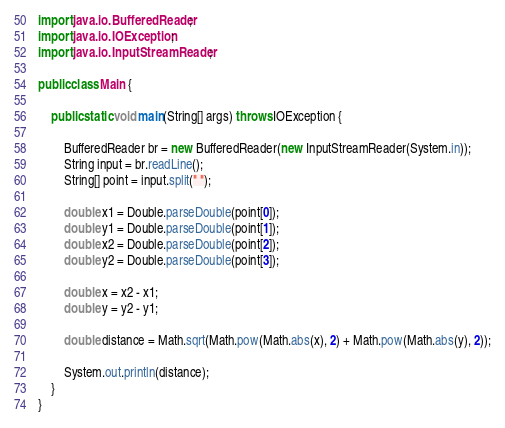<code> <loc_0><loc_0><loc_500><loc_500><_Java_>import java.io.BufferedReader;
import java.io.IOException;
import java.io.InputStreamReader;

public class Main {

    public static void main(String[] args) throws IOException {

        BufferedReader br = new BufferedReader(new InputStreamReader(System.in));
        String input = br.readLine();
        String[] point = input.split(" ");

        double x1 = Double.parseDouble(point[0]);
        double y1 = Double.parseDouble(point[1]);
        double x2 = Double.parseDouble(point[2]);
        double y2 = Double.parseDouble(point[3]);

        double x = x2 - x1;
        double y = y2 - y1;

        double distance = Math.sqrt(Math.pow(Math.abs(x), 2) + Math.pow(Math.abs(y), 2));

        System.out.println(distance);
    }
}</code> 